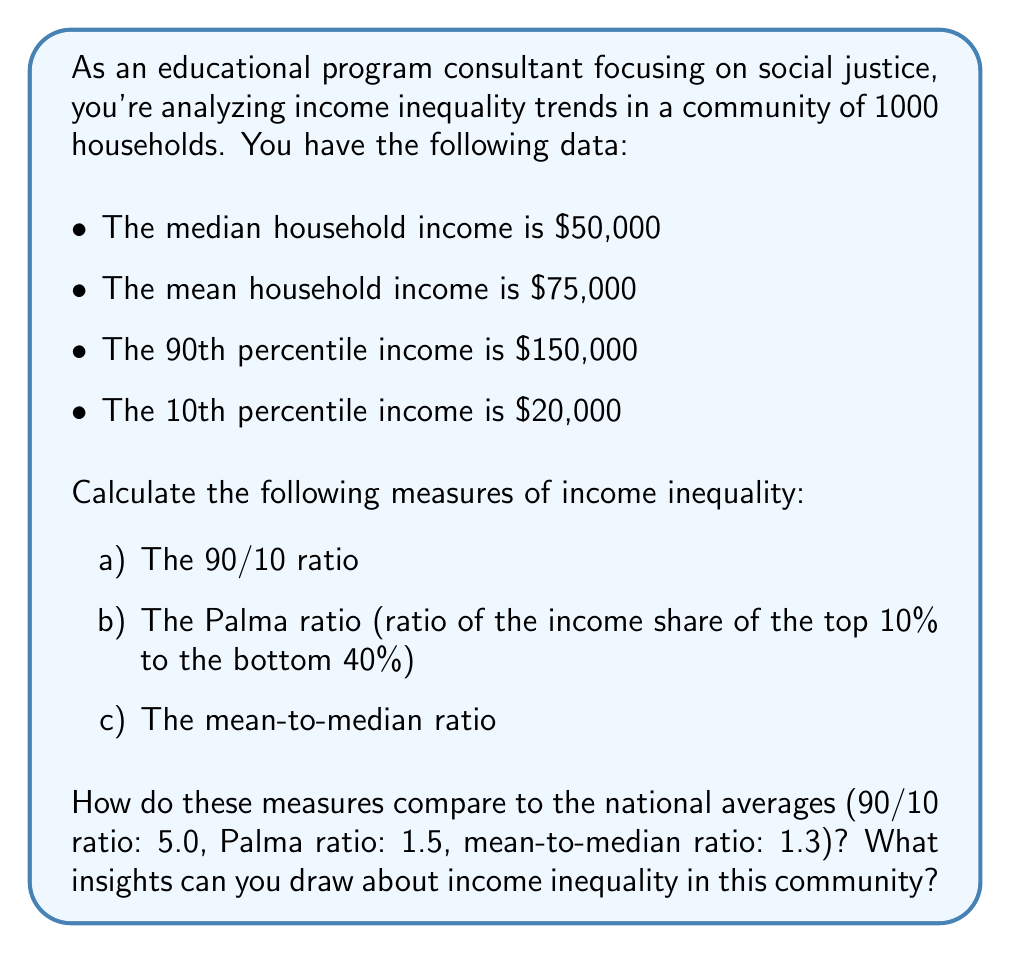Can you solve this math problem? Let's calculate each measure step by step:

a) 90/10 ratio:
The 90/10 ratio is calculated by dividing the 90th percentile income by the 10th percentile income.

$$ \text{90/10 ratio} = \frac{90\text{th percentile income}}{10\text{th percentile income}} = \frac{150,000}{20,000} = 7.5 $$

b) Palma ratio:
To calculate the Palma ratio, we need to estimate the income shares of the top 10% and bottom 40%. We can use the given percentiles and mean income to approximate these shares.

Top 10% share:
$$ \text{Top 10% share} \approx \frac{(150,000 - 75,000) \times 0.1 \times 1000}{75,000 \times 1000} = 0.1 \text{ or } 10\% $$

Bottom 40% share:
$$ \text{Bottom 40% share} \approx \frac{(50,000 - 20,000) \times 0.4 \times 1000}{75,000 \times 1000} = 0.16 \text{ or } 16\% $$

Palma ratio:
$$ \text{Palma ratio} = \frac{\text{Top 10% share}}{\text{Bottom 40% share}} = \frac{0.1}{0.16} = 0.625 $$

c) Mean-to-median ratio:
$$ \text{Mean-to-median ratio} = \frac{\text{Mean income}}{\text{Median income}} = \frac{75,000}{50,000} = 1.5 $$

Comparison to national averages:
- 90/10 ratio: 7.5 (community) vs 5.0 (national)
- Palma ratio: 0.625 (community) vs 1.5 (national)
- Mean-to-median ratio: 1.5 (community) vs 1.3 (national)

Insights:
1. The 90/10 ratio is significantly higher than the national average, indicating a wider gap between the highest and lowest earners in the community.
2. The Palma ratio is lower than the national average, suggesting that the income share of the top 10% relative to the bottom 40% is actually smaller in this community.
3. The mean-to-median ratio is higher than the national average, indicating that the community's income distribution is more right-skewed, with some very high incomes pulling the mean above the median.

These measures suggest that while there is significant inequality between the highest and lowest earners, the middle class in this community may be relatively better off compared to the national average. The community shows a complex inequality pattern that requires careful interpretation and targeted interventions.
Answer: a) 90/10 ratio: 7.5
b) Palma ratio: 0.625
c) Mean-to-median ratio: 1.5

The community shows higher inequality between extreme income levels (90/10 ratio) and more income concentration at the top (mean-to-median ratio) compared to national averages. However, the Palma ratio suggests a more equitable distribution between the top 10% and bottom 40% than the national average. 